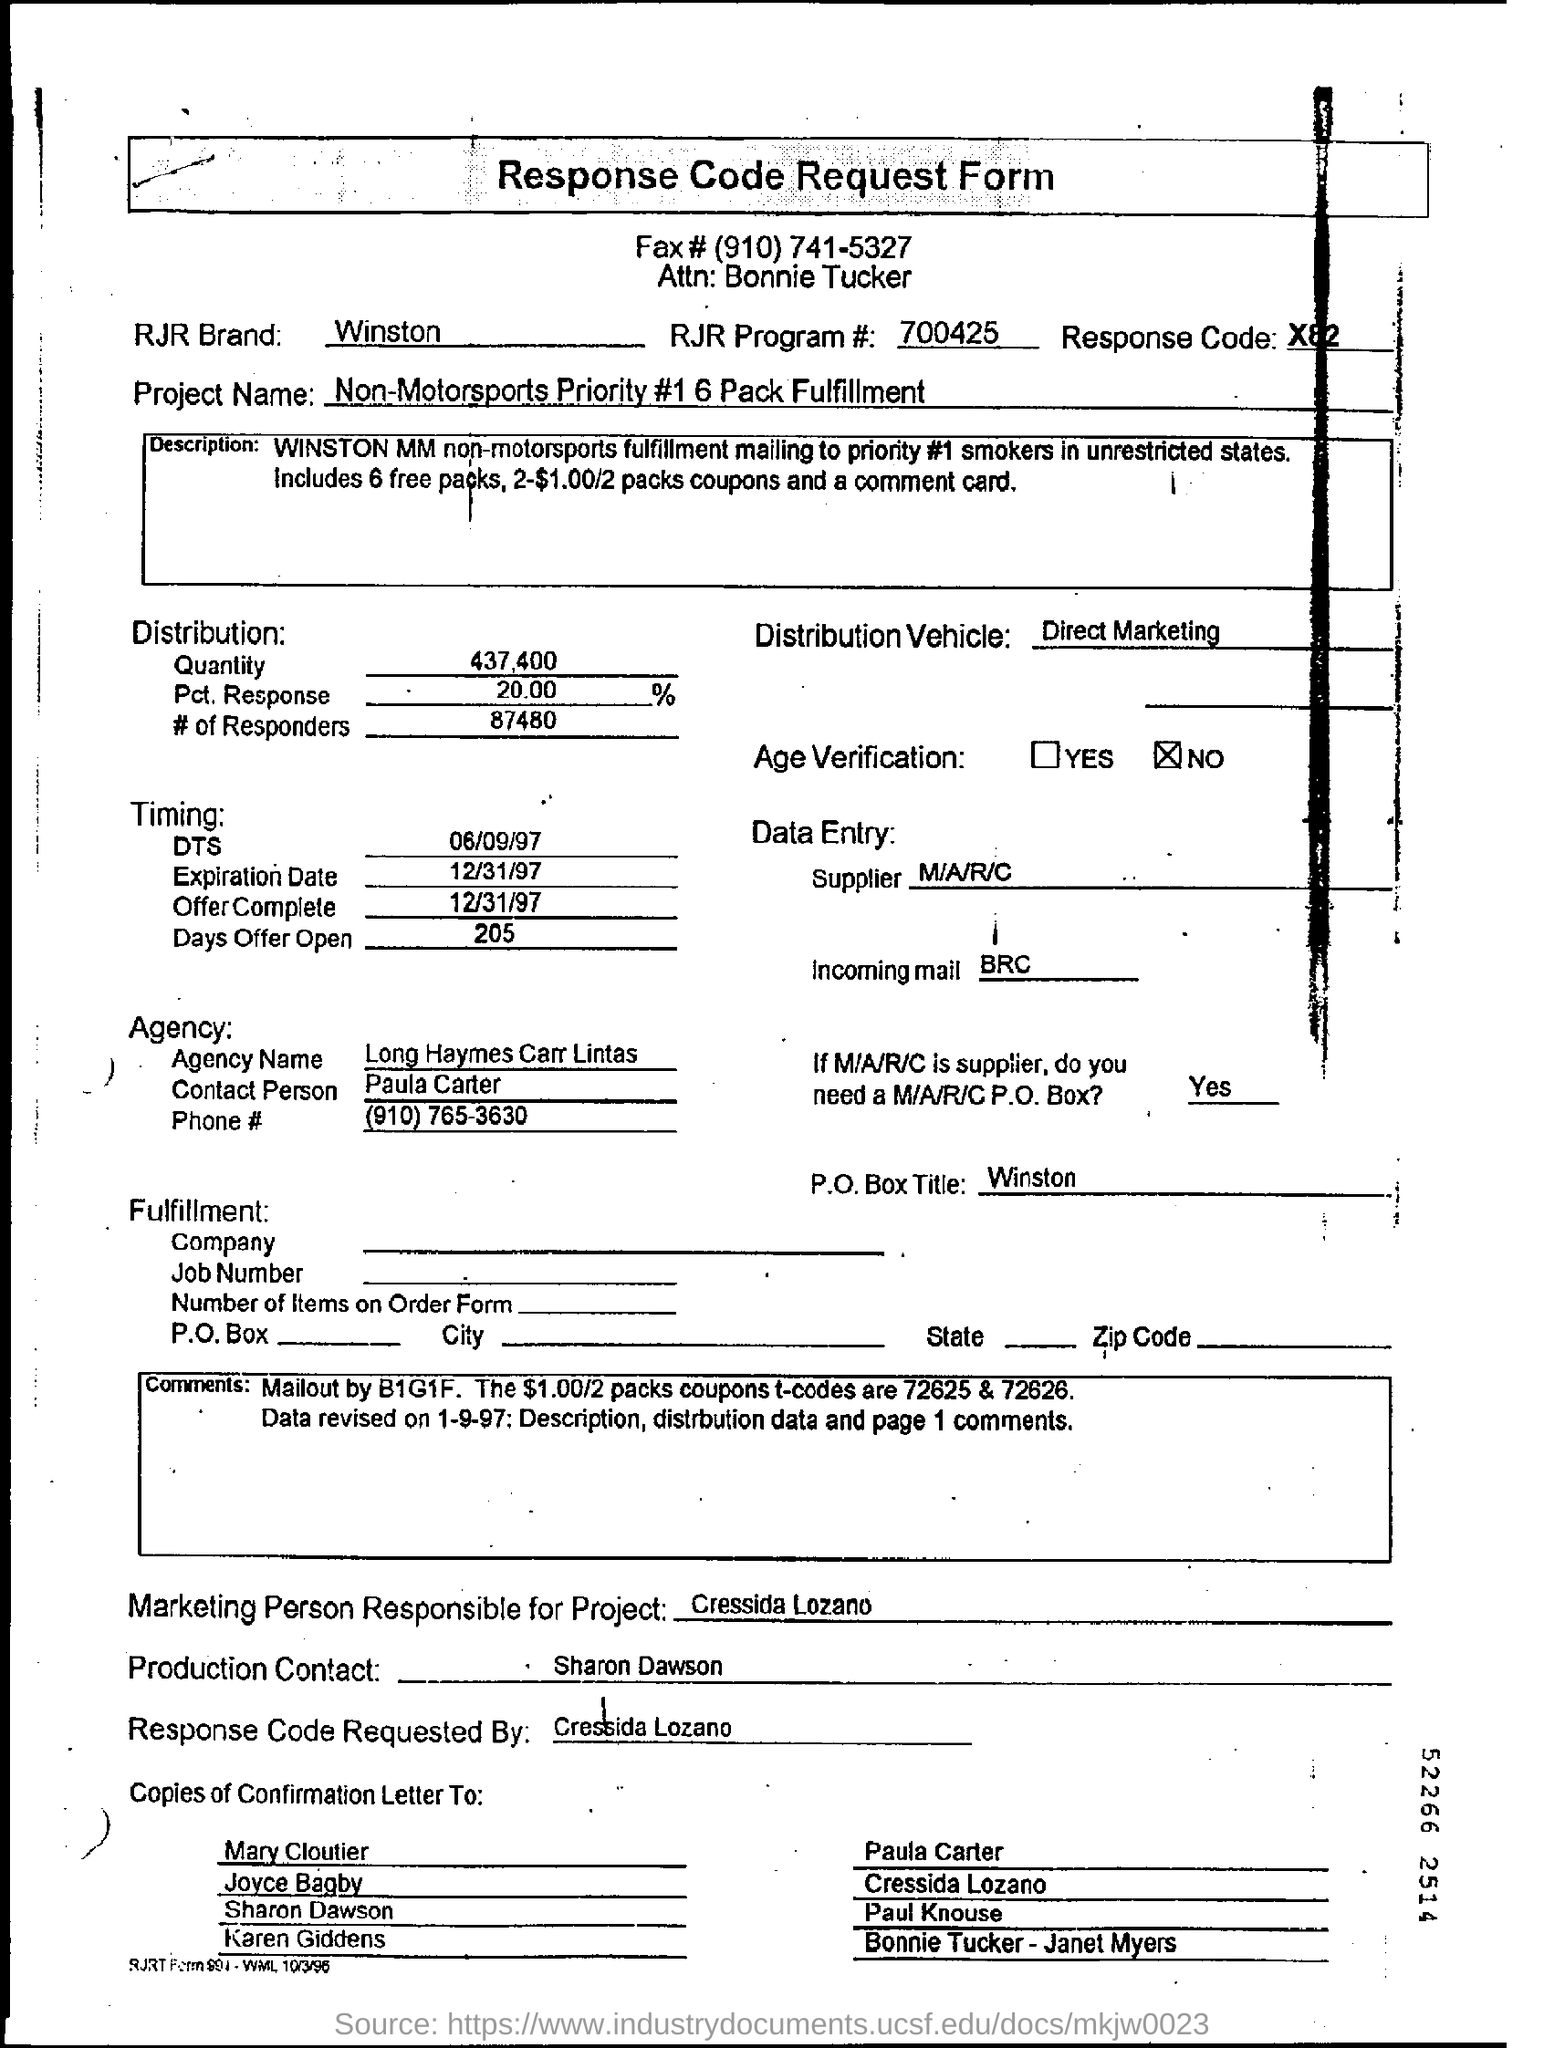What is the RJR Brand mentioned?
Make the answer very short. Winston. What is the RJR Program # number?
Make the answer very short. 700425. What is the Response Code mentioned?
Provide a succinct answer. X82. What is the Project Name?
Your response must be concise. Non-Motorsports Priority #1 6 Pack Fulfillment. 